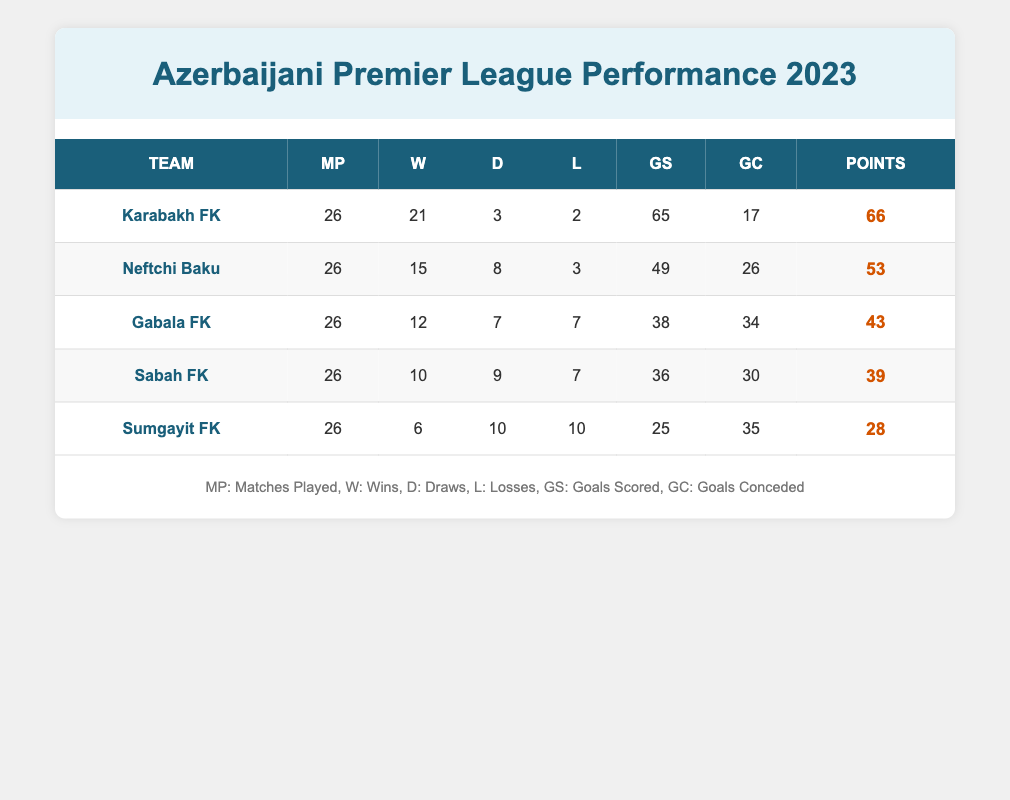What is the total number of matches played by all teams in the table? To find the total matches played, sum the 'Matches Played' values for each team: 26 (Karabakh FK) + 26 (Neftchi Baku) + 26 (Gabala FK) + 26 (Sabah FK) + 26 (Sumgayit FK) = 130.
Answer: 130 Which team has the highest number of goals scored? Karabakh FK scored 65 goals, which is the highest compared to the other teams: Neftchi Baku (49), Gabala FK (38), Sabah FK (36), and Sumgayit FK (25).
Answer: Karabakh FK What is the goal difference for Neftchi Baku? The goal difference is calculated by subtracting 'Goals Conceded' from 'Goals Scored'. For Neftchi Baku: 49 (Goals Scored) - 26 (Goals Conceded) = 23.
Answer: 23 Did any team have more draws than losses? By examining the 'Draws' and 'Losses', we see that Gabala FK had 7 draws and 7 losses, Sabah FK had 9 draws and 7 losses, and Neftchi Baku had 8 draws and 3 losses. Hence, Sabah FK and Neftchi Baku had more draws than losses, confirming the statement is true.
Answer: Yes What team had the lowest number of points, and how many points did they have? Sumgayit FK had the lowest points with a total of 28. This is less than any other team's points: Karabakh FK (66), Neftchi Baku (53), Gabala FK (43), and Sabah FK (39).
Answer: Sumgayit FK, 28 If we average the goals scored by all teams, what would that be? To find the average goals scored, sum them up: 65 (Karabakh FK) + 49 (Neftchi Baku) + 38 (Gabala FK) + 36 (Sabah FK) + 25 (Sumgayit FK) = 213. Then divide by the number of teams: 213 / 5 = 42.6.
Answer: 42.6 Which team conceded the fewest goals and how many did they concede? Karabakh FK conceded the fewest goals with a total of 17. The other teams conceded 26 (Neftchi Baku), 34 (Gabala FK), 30 (Sabah FK), and 35 (Sumgayit FK), confirming Karabakh FK's position clearly.
Answer: Karabakh FK, 17 Is it true that all teams had at least 25 goals scored? Sumgayit FK scored only 25 goals, while other teams scored more. Since all teams scored at least this amount, the statement is true.
Answer: Yes How many total points did the top two teams earn? The top two teams are Karabakh FK with 66 points and Neftchi Baku with 53 points. Adding these together results in 66 + 53 = 119 points.
Answer: 119 